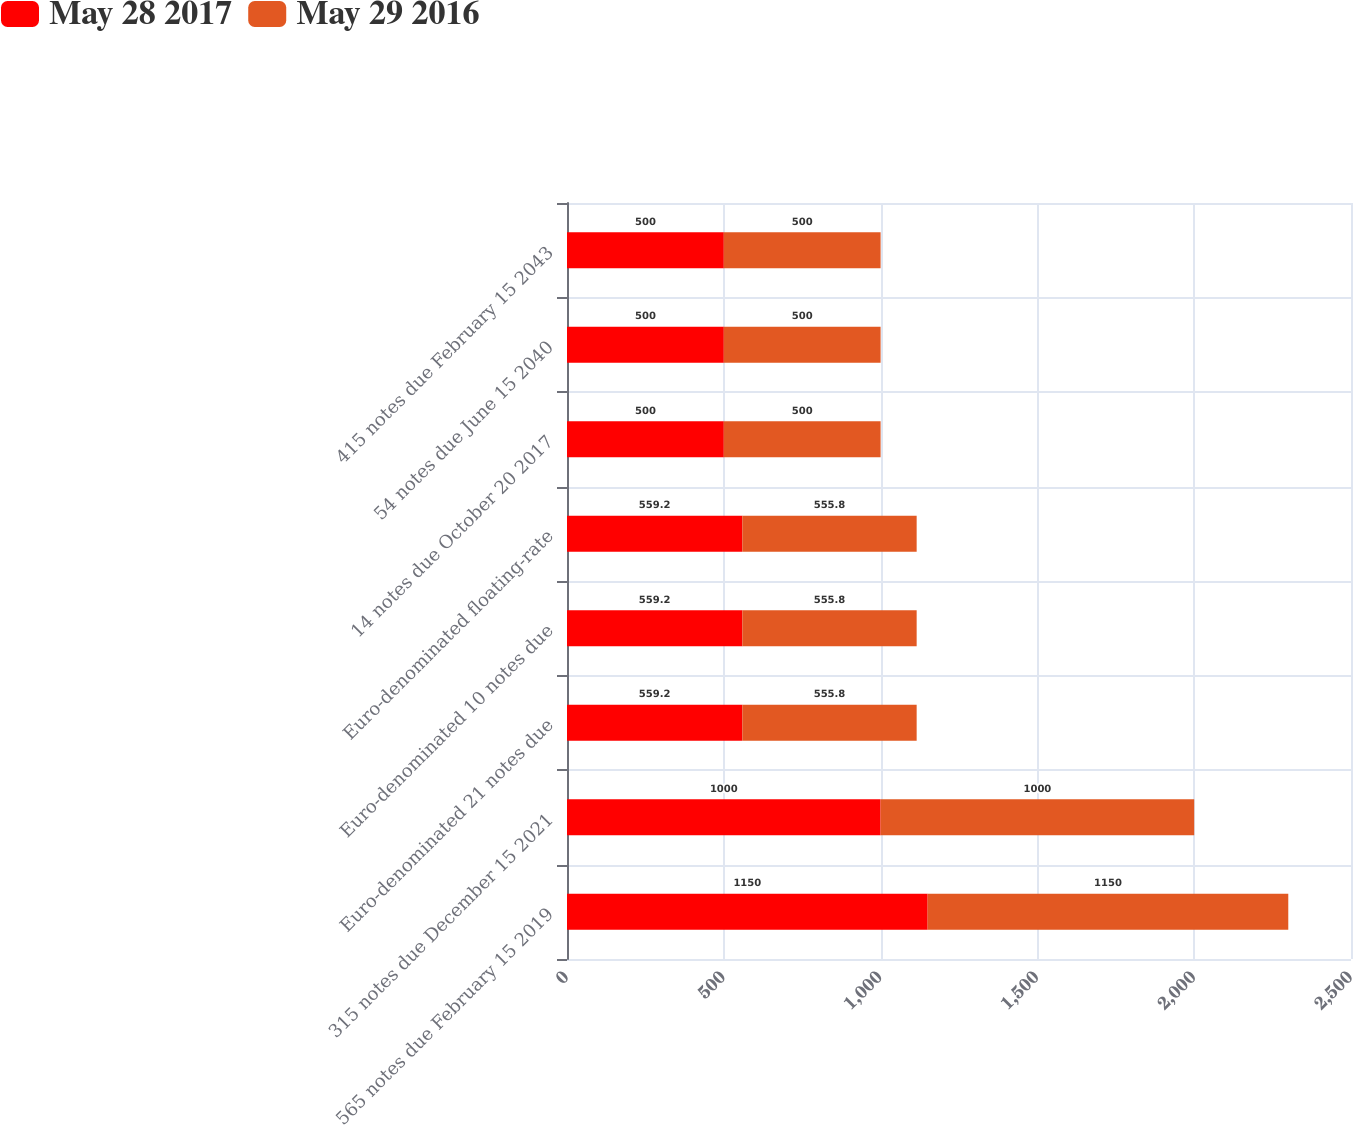Convert chart. <chart><loc_0><loc_0><loc_500><loc_500><stacked_bar_chart><ecel><fcel>565 notes due February 15 2019<fcel>315 notes due December 15 2021<fcel>Euro-denominated 21 notes due<fcel>Euro-denominated 10 notes due<fcel>Euro-denominated floating-rate<fcel>14 notes due October 20 2017<fcel>54 notes due June 15 2040<fcel>415 notes due February 15 2043<nl><fcel>May 28 2017<fcel>1150<fcel>1000<fcel>559.2<fcel>559.2<fcel>559.2<fcel>500<fcel>500<fcel>500<nl><fcel>May 29 2016<fcel>1150<fcel>1000<fcel>555.8<fcel>555.8<fcel>555.8<fcel>500<fcel>500<fcel>500<nl></chart> 